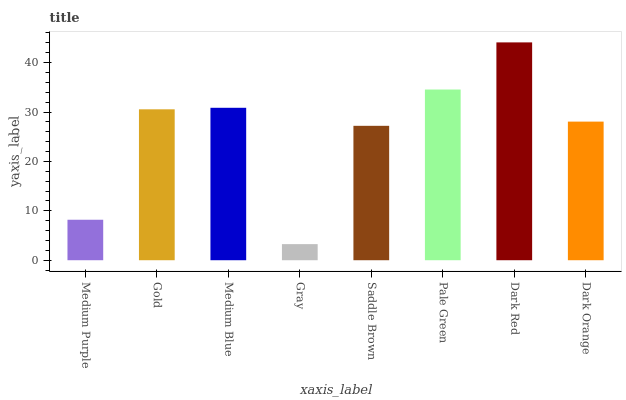Is Gray the minimum?
Answer yes or no. Yes. Is Dark Red the maximum?
Answer yes or no. Yes. Is Gold the minimum?
Answer yes or no. No. Is Gold the maximum?
Answer yes or no. No. Is Gold greater than Medium Purple?
Answer yes or no. Yes. Is Medium Purple less than Gold?
Answer yes or no. Yes. Is Medium Purple greater than Gold?
Answer yes or no. No. Is Gold less than Medium Purple?
Answer yes or no. No. Is Gold the high median?
Answer yes or no. Yes. Is Dark Orange the low median?
Answer yes or no. Yes. Is Pale Green the high median?
Answer yes or no. No. Is Saddle Brown the low median?
Answer yes or no. No. 